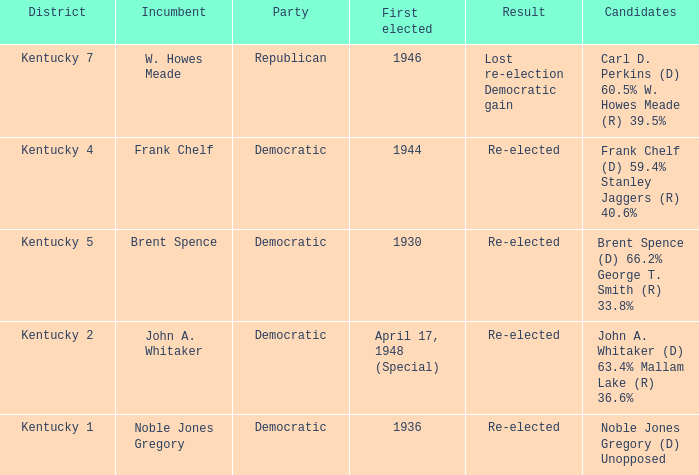What was the result of the election incumbent Brent Spence took place in? Re-elected. 